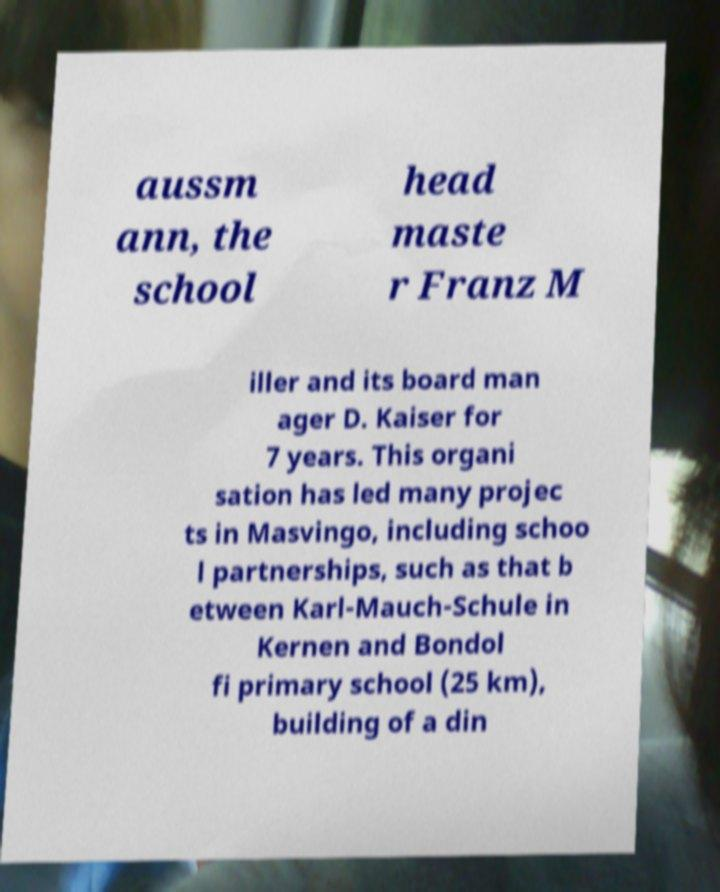Can you accurately transcribe the text from the provided image for me? aussm ann, the school head maste r Franz M iller and its board man ager D. Kaiser for 7 years. This organi sation has led many projec ts in Masvingo, including schoo l partnerships, such as that b etween Karl-Mauch-Schule in Kernen and Bondol fi primary school (25 km), building of a din 